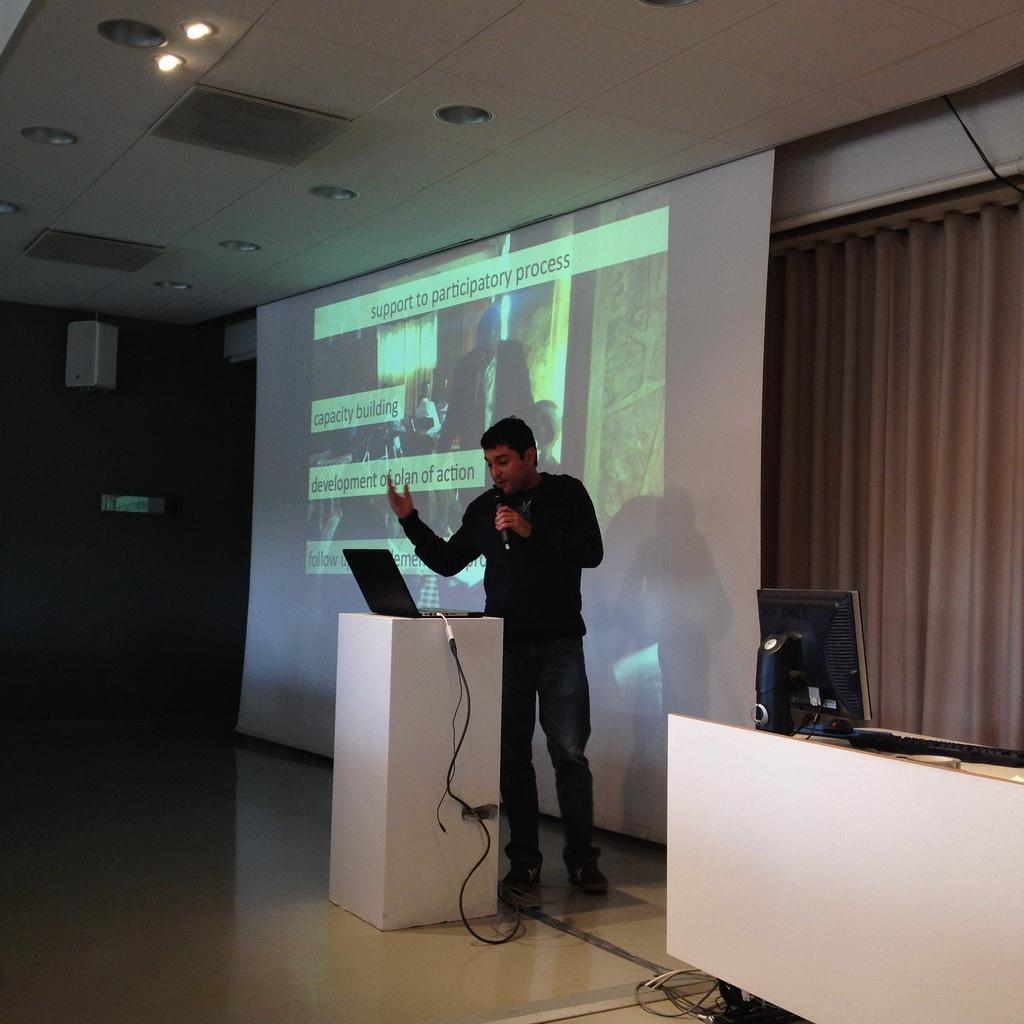<image>
Summarize the visual content of the image. A man with a microphone gives a talk about support to participatory process. 